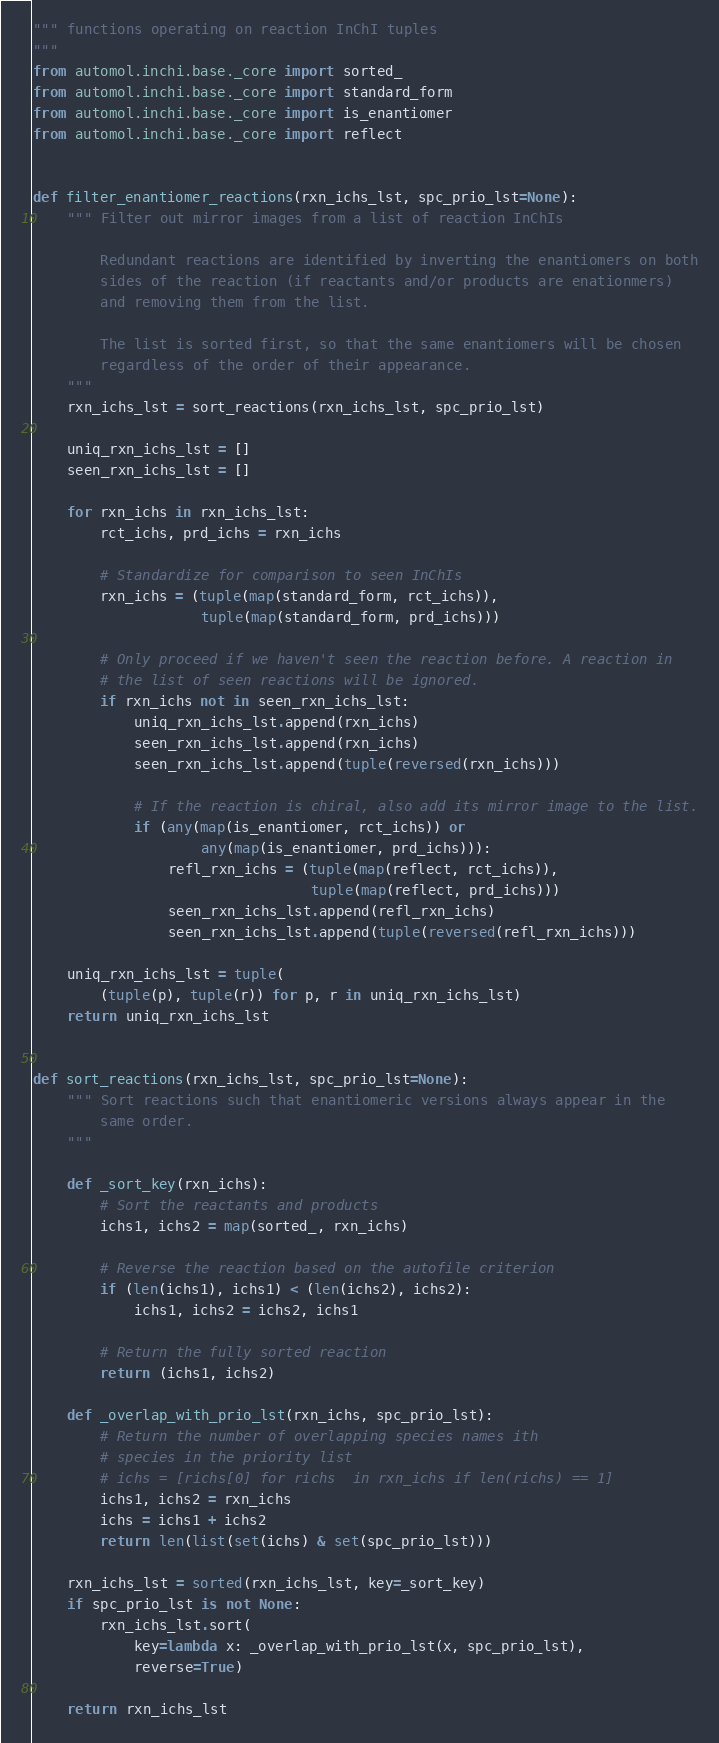Convert code to text. <code><loc_0><loc_0><loc_500><loc_500><_Python_>""" functions operating on reaction InChI tuples
"""
from automol.inchi.base._core import sorted_
from automol.inchi.base._core import standard_form
from automol.inchi.base._core import is_enantiomer
from automol.inchi.base._core import reflect


def filter_enantiomer_reactions(rxn_ichs_lst, spc_prio_lst=None):
    """ Filter out mirror images from a list of reaction InChIs

        Redundant reactions are identified by inverting the enantiomers on both
        sides of the reaction (if reactants and/or products are enationmers)
        and removing them from the list.

        The list is sorted first, so that the same enantiomers will be chosen
        regardless of the order of their appearance.
    """
    rxn_ichs_lst = sort_reactions(rxn_ichs_lst, spc_prio_lst)

    uniq_rxn_ichs_lst = []
    seen_rxn_ichs_lst = []

    for rxn_ichs in rxn_ichs_lst:
        rct_ichs, prd_ichs = rxn_ichs

        # Standardize for comparison to seen InChIs
        rxn_ichs = (tuple(map(standard_form, rct_ichs)),
                    tuple(map(standard_form, prd_ichs)))

        # Only proceed if we haven't seen the reaction before. A reaction in
        # the list of seen reactions will be ignored.
        if rxn_ichs not in seen_rxn_ichs_lst:
            uniq_rxn_ichs_lst.append(rxn_ichs)
            seen_rxn_ichs_lst.append(rxn_ichs)
            seen_rxn_ichs_lst.append(tuple(reversed(rxn_ichs)))

            # If the reaction is chiral, also add its mirror image to the list.
            if (any(map(is_enantiomer, rct_ichs)) or
                    any(map(is_enantiomer, prd_ichs))):
                refl_rxn_ichs = (tuple(map(reflect, rct_ichs)),
                                 tuple(map(reflect, prd_ichs)))
                seen_rxn_ichs_lst.append(refl_rxn_ichs)
                seen_rxn_ichs_lst.append(tuple(reversed(refl_rxn_ichs)))

    uniq_rxn_ichs_lst = tuple(
        (tuple(p), tuple(r)) for p, r in uniq_rxn_ichs_lst)
    return uniq_rxn_ichs_lst


def sort_reactions(rxn_ichs_lst, spc_prio_lst=None):
    """ Sort reactions such that enantiomeric versions always appear in the
        same order.
    """

    def _sort_key(rxn_ichs):
        # Sort the reactants and products
        ichs1, ichs2 = map(sorted_, rxn_ichs)

        # Reverse the reaction based on the autofile criterion
        if (len(ichs1), ichs1) < (len(ichs2), ichs2):
            ichs1, ichs2 = ichs2, ichs1

        # Return the fully sorted reaction
        return (ichs1, ichs2)

    def _overlap_with_prio_lst(rxn_ichs, spc_prio_lst):
        # Return the number of overlapping species names ith
        # species in the priority list
        # ichs = [richs[0] for richs  in rxn_ichs if len(richs) == 1]
        ichs1, ichs2 = rxn_ichs
        ichs = ichs1 + ichs2
        return len(list(set(ichs) & set(spc_prio_lst)))

    rxn_ichs_lst = sorted(rxn_ichs_lst, key=_sort_key)
    if spc_prio_lst is not None:
        rxn_ichs_lst.sort(
            key=lambda x: _overlap_with_prio_lst(x, spc_prio_lst),
            reverse=True)

    return rxn_ichs_lst
</code> 